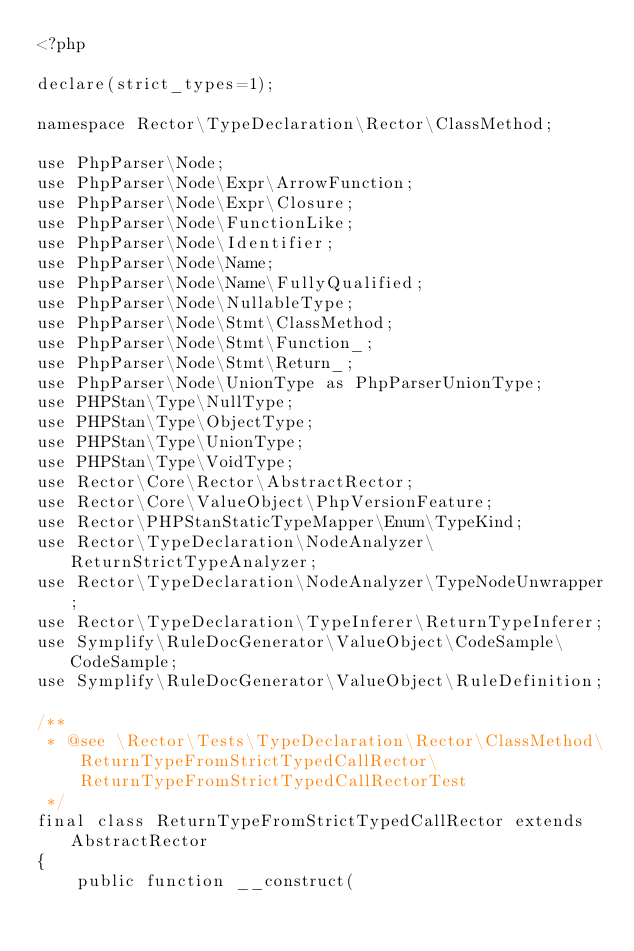Convert code to text. <code><loc_0><loc_0><loc_500><loc_500><_PHP_><?php

declare(strict_types=1);

namespace Rector\TypeDeclaration\Rector\ClassMethod;

use PhpParser\Node;
use PhpParser\Node\Expr\ArrowFunction;
use PhpParser\Node\Expr\Closure;
use PhpParser\Node\FunctionLike;
use PhpParser\Node\Identifier;
use PhpParser\Node\Name;
use PhpParser\Node\Name\FullyQualified;
use PhpParser\Node\NullableType;
use PhpParser\Node\Stmt\ClassMethod;
use PhpParser\Node\Stmt\Function_;
use PhpParser\Node\Stmt\Return_;
use PhpParser\Node\UnionType as PhpParserUnionType;
use PHPStan\Type\NullType;
use PHPStan\Type\ObjectType;
use PHPStan\Type\UnionType;
use PHPStan\Type\VoidType;
use Rector\Core\Rector\AbstractRector;
use Rector\Core\ValueObject\PhpVersionFeature;
use Rector\PHPStanStaticTypeMapper\Enum\TypeKind;
use Rector\TypeDeclaration\NodeAnalyzer\ReturnStrictTypeAnalyzer;
use Rector\TypeDeclaration\NodeAnalyzer\TypeNodeUnwrapper;
use Rector\TypeDeclaration\TypeInferer\ReturnTypeInferer;
use Symplify\RuleDocGenerator\ValueObject\CodeSample\CodeSample;
use Symplify\RuleDocGenerator\ValueObject\RuleDefinition;

/**
 * @see \Rector\Tests\TypeDeclaration\Rector\ClassMethod\ReturnTypeFromStrictTypedCallRector\ReturnTypeFromStrictTypedCallRectorTest
 */
final class ReturnTypeFromStrictTypedCallRector extends AbstractRector
{
    public function __construct(</code> 